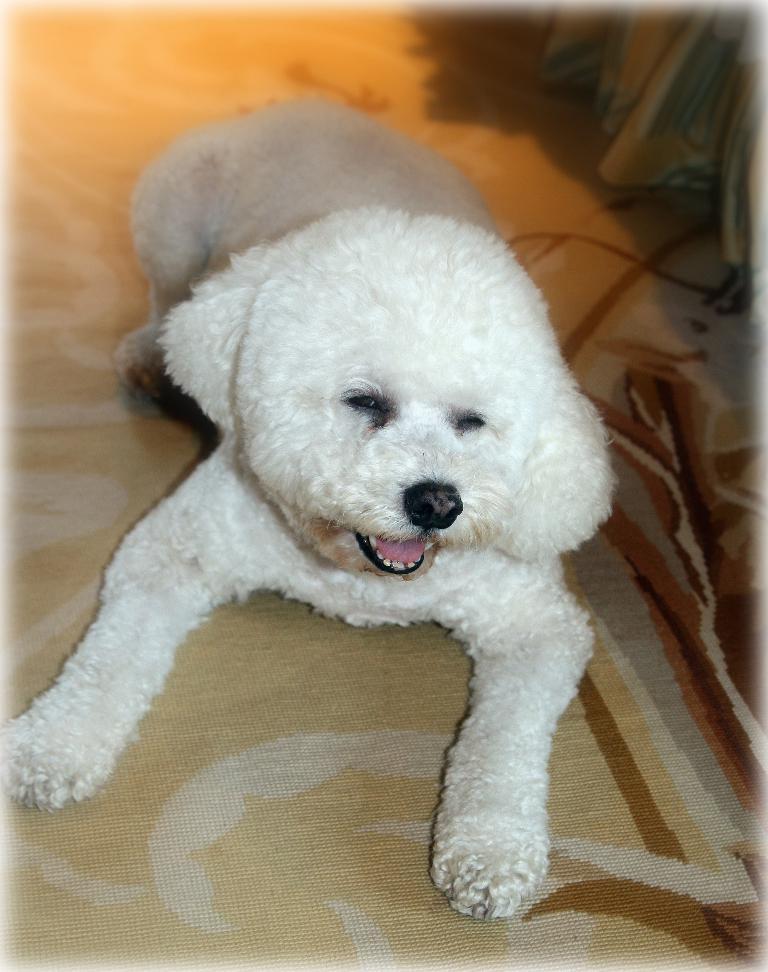In one or two sentences, can you explain what this image depicts? In this image I can see white colour dog. I can also see this image is little bit blurry from background. 